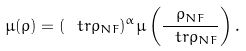Convert formula to latex. <formula><loc_0><loc_0><loc_500><loc_500>\mu ( \rho ) = ( \ t r \rho _ { N F } ) ^ { \alpha } \mu \left ( \frac { \rho _ { N F } } { \ t r \rho _ { N F } } \right ) .</formula> 